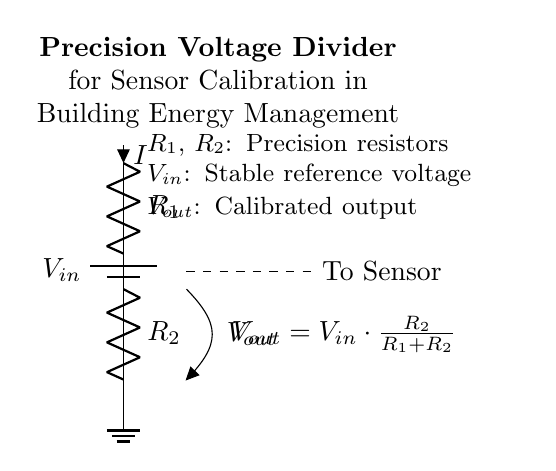What is the input voltage in the circuit? The input voltage is labeled as V_in, and it is represented as the voltage supplied by the battery at the top of the circuit.
Answer: V_in What are the resistance values represented in the circuit diagram? The circuit shows two resistors labeled R_1 and R_2, but their numerical values are not provided in the diagram itself.
Answer: R_1, R_2 What is the output voltage formula given in the circuit? The output voltage is described by the equation V_out = V_in * (R_2 / (R_1 + R_2)), which defines how the output voltage is derived from the input voltage and the resistances.
Answer: V_out = V_in * (R_2 / (R_1 + R_2)) Which direction does the current flow in the voltage divider? The current flows from the input voltage V_in through resistor R_1, then through R_2, and finally to ground, following a top-to-bottom direction.
Answer: Top to bottom What role do precision resistors play in this circuit? Precision resistors provide accurate resistance values, which are crucial for ensuring that the output voltage V_out is stable and predictable for sensor calibration in building energy management systems.
Answer: Accuracy How does changing R_1 affect V_out? Increasing R_1 decreases the output voltage V_out, because the output depends on the ratio of R_2 to the total resistance (R_1 + R_2) as shown in the formula.
Answer: Decreases V_out 